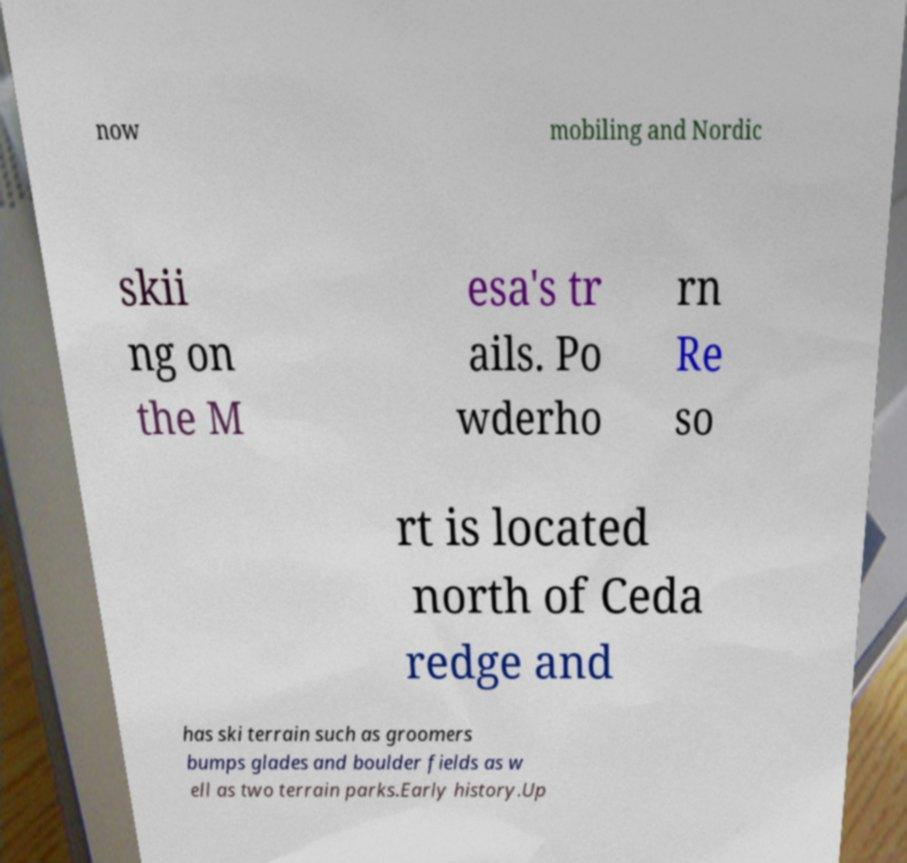Can you accurately transcribe the text from the provided image for me? now mobiling and Nordic skii ng on the M esa's tr ails. Po wderho rn Re so rt is located north of Ceda redge and has ski terrain such as groomers bumps glades and boulder fields as w ell as two terrain parks.Early history.Up 